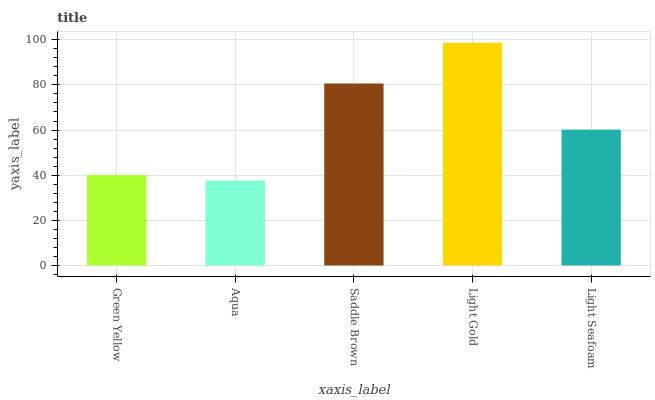Is Aqua the minimum?
Answer yes or no. Yes. Is Light Gold the maximum?
Answer yes or no. Yes. Is Saddle Brown the minimum?
Answer yes or no. No. Is Saddle Brown the maximum?
Answer yes or no. No. Is Saddle Brown greater than Aqua?
Answer yes or no. Yes. Is Aqua less than Saddle Brown?
Answer yes or no. Yes. Is Aqua greater than Saddle Brown?
Answer yes or no. No. Is Saddle Brown less than Aqua?
Answer yes or no. No. Is Light Seafoam the high median?
Answer yes or no. Yes. Is Light Seafoam the low median?
Answer yes or no. Yes. Is Light Gold the high median?
Answer yes or no. No. Is Light Gold the low median?
Answer yes or no. No. 